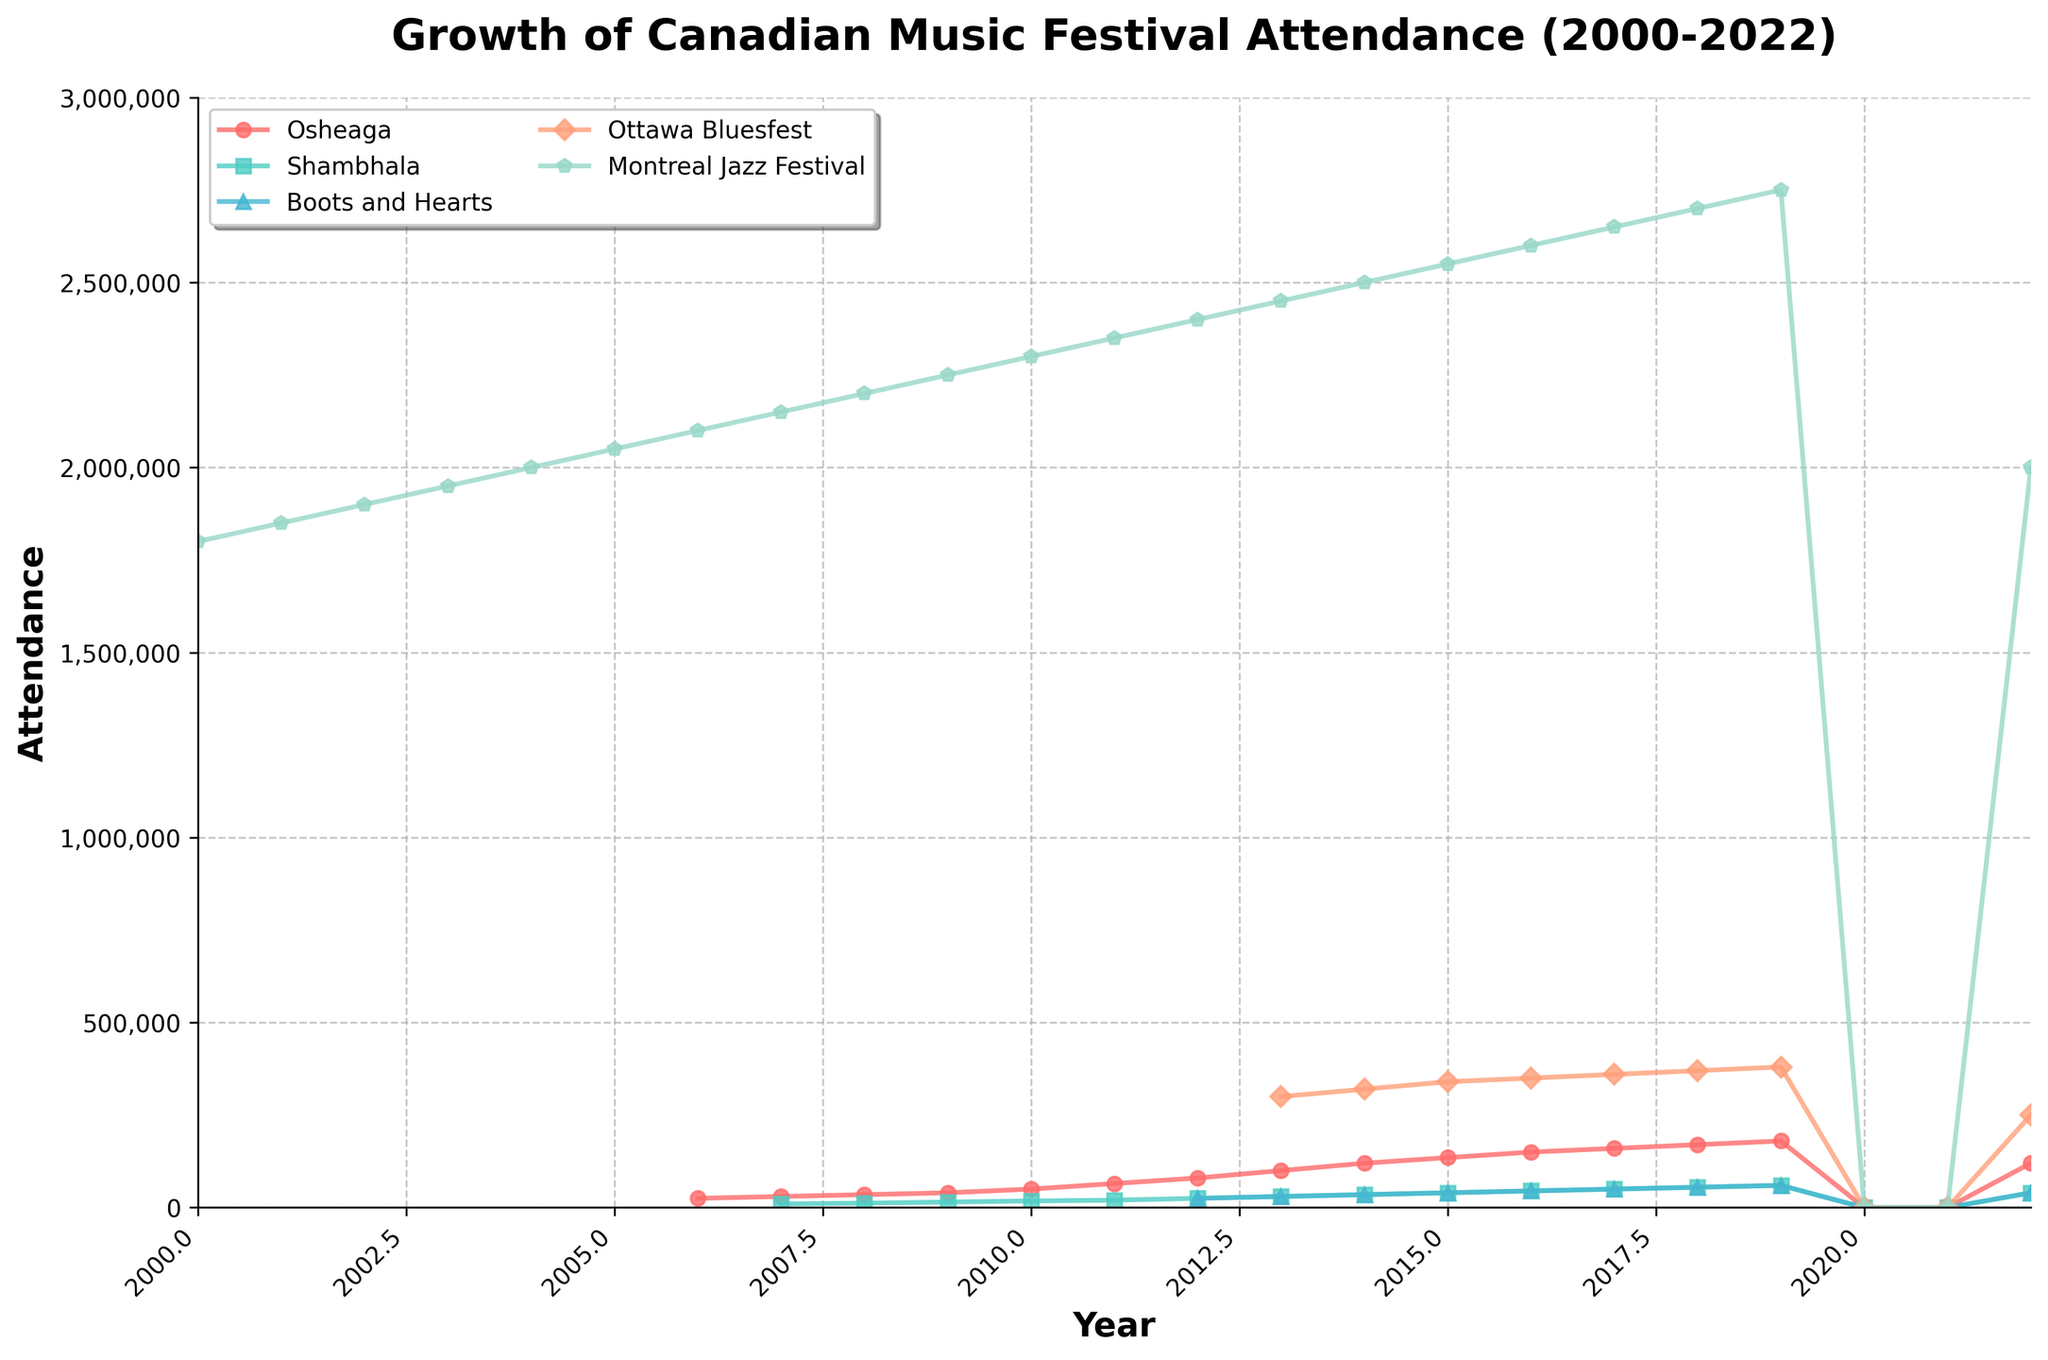Which festival had the highest attendance in 2019? Look at the 2019 data points and identify the highest value. The Montreal Jazz Festival has the highest attendance of 2,750,000.
Answer: Montreal Jazz Festival What was the overall trend for Osheaga festival attendance from 2006 to 2019? Osheaga festival attendance shows an increasing trend with values starting from 25,000 in 2006 and reaching 180,000 in 2019.
Answer: Increasing trend How did the attendance of Shambhala compare to Boots and Hearts in 2016? Both events had the same attendance of 45,000 in 2016.
Answer: Equal attendance What's the total attendance for Osheaga and Ottawa Bluesfest in 2017? Add the 2017 attendance values for Osheaga (160,000) and Ottawa Bluesfest (360,000): 160,000 + 360,000 = 520,000.
Answer: 520,000 Which festival showed a decline in attendance after 2019, and by how much? Compare the values of each festival in 2019 and 2022. Montreal Jazz Festival showed a decline from 2,750,000 in 2019 to 2,000,000 in 2022, a decrease of 750,000.
Answer: Montreal Jazz Festival, 750,000 What is the mean attendance for Boots and Hearts from 2013 to 2018? Sum the values for Boots and Hearts from 2013 to 2018 and divide by the number of years: (30000+35000+40000+45000+50000+55000) / 6 = 258,333.
Answer: 258,333 Has the Ottawa Bluesfest attendance ever exceeded 350,000? If yes, in which years? Check the attendance values for Ottawa Bluesfest and find years with values over 350,000. Ottawa Bluesfest exceeded 350,000 in 2017, 2018, and 2019.
Answer: Yes, 2017, 2018, 2019 In which year did Osheaga see the highest increase in attendance from the previous year? Calculate the year-over-year difference in Osheaga's attendance and find the maximum. The highest increase was between 2011 (65,000) and 2012 (80,000), an increase of 15,000.
Answer: 2012 Did any festivals not record attendance in the years 2020 and 2021? Look at the data for 2020 and 2021 for all festivals, which show all values are zero.
Answer: All festivals What is the general trend observed in the overall attendance of Montreal Jazz Festival from 2000 to 2022? The trend shows an overall increase in attendance peaking at 2,750,000 in 2019, with a decline in 2022 to 2,000,000.
Answer: Increasing trend with a decline in 2022 